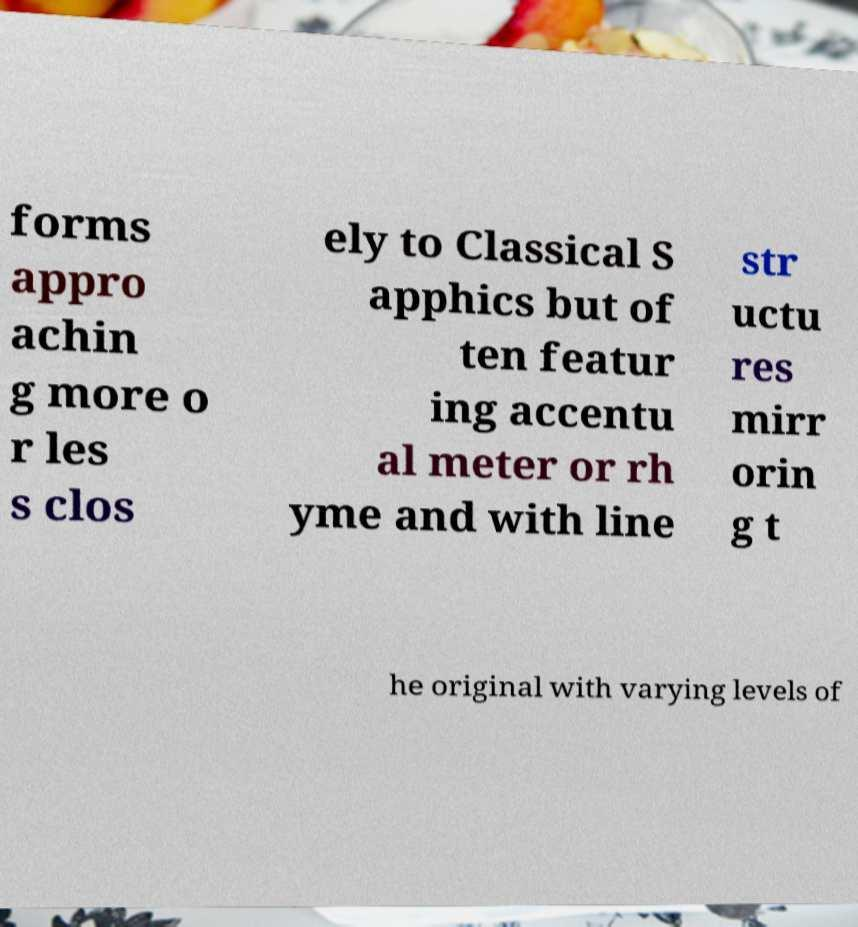Can you read and provide the text displayed in the image?This photo seems to have some interesting text. Can you extract and type it out for me? forms appro achin g more o r les s clos ely to Classical S apphics but of ten featur ing accentu al meter or rh yme and with line str uctu res mirr orin g t he original with varying levels of 